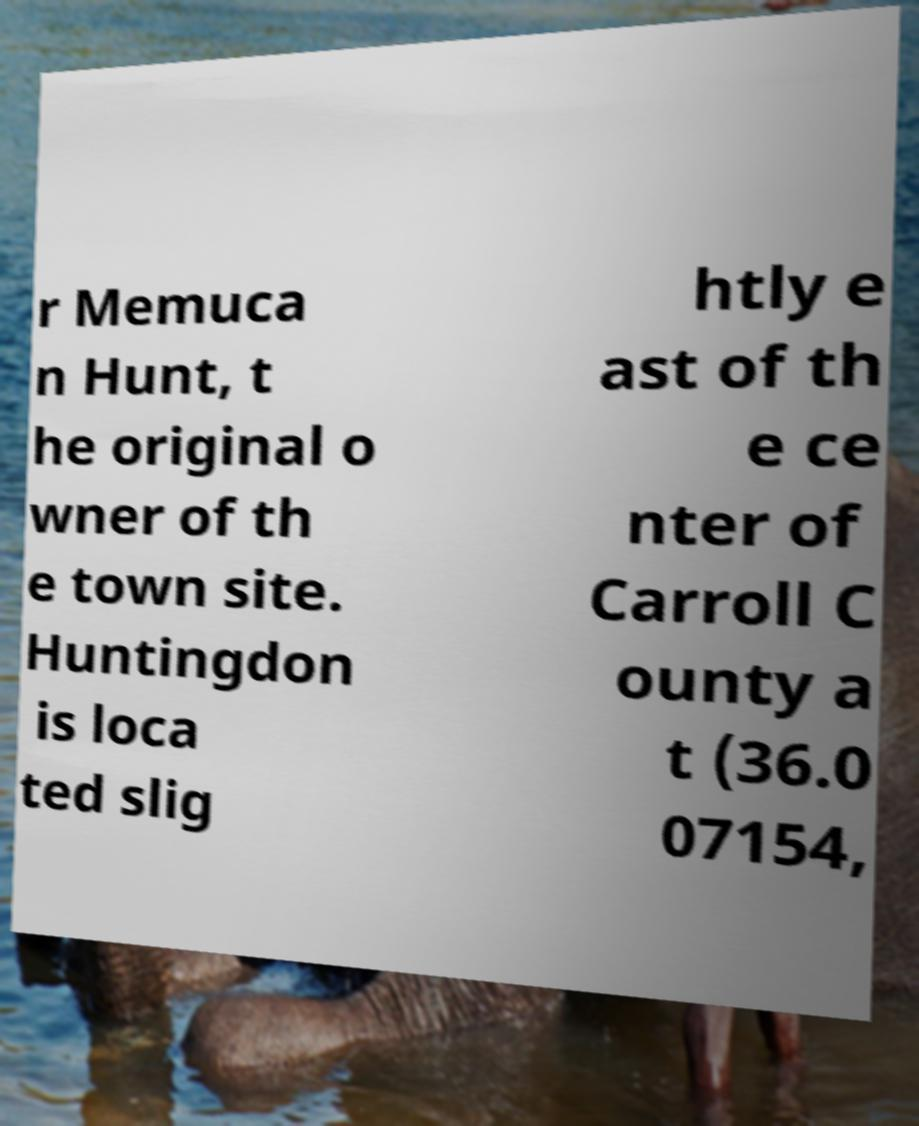Could you assist in decoding the text presented in this image and type it out clearly? r Memuca n Hunt, t he original o wner of th e town site. Huntingdon is loca ted slig htly e ast of th e ce nter of Carroll C ounty a t (36.0 07154, 